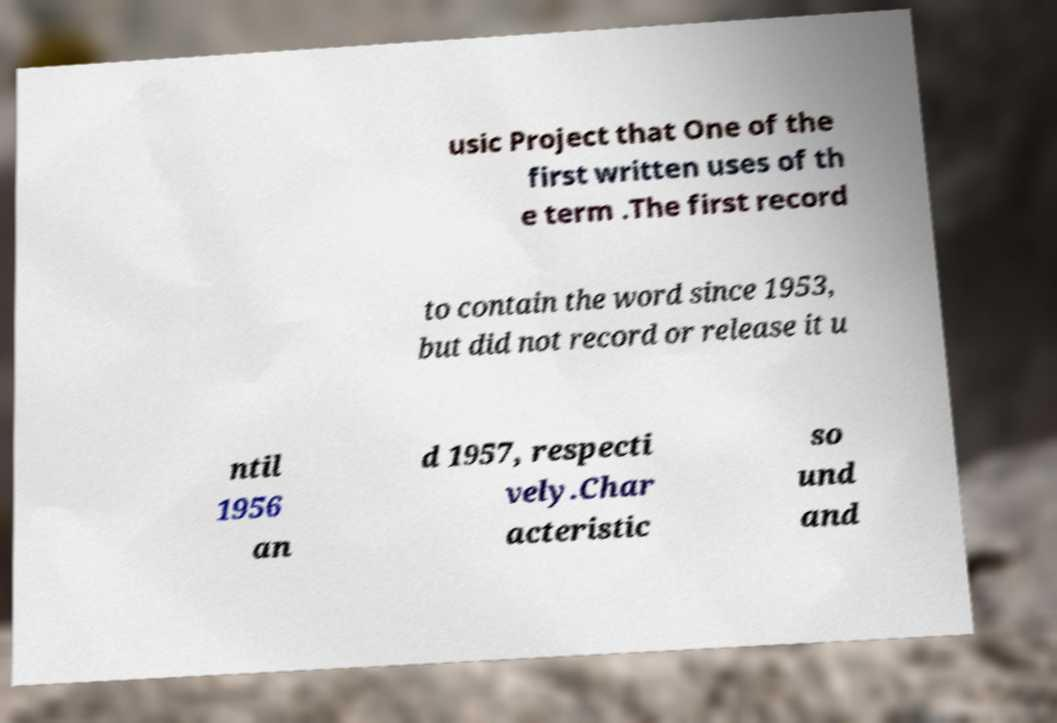Can you accurately transcribe the text from the provided image for me? usic Project that One of the first written uses of th e term .The first record to contain the word since 1953, but did not record or release it u ntil 1956 an d 1957, respecti vely.Char acteristic so und and 